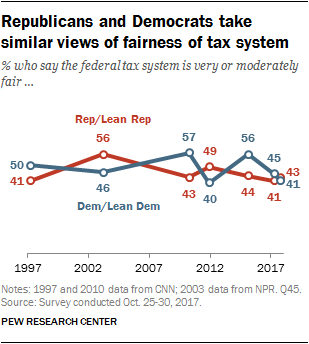List a handful of essential elements in this visual. Democrats are associated with the color blue. The difference between the median opinion of Democrats and the smaller mode of Republicans is equal to 5. 